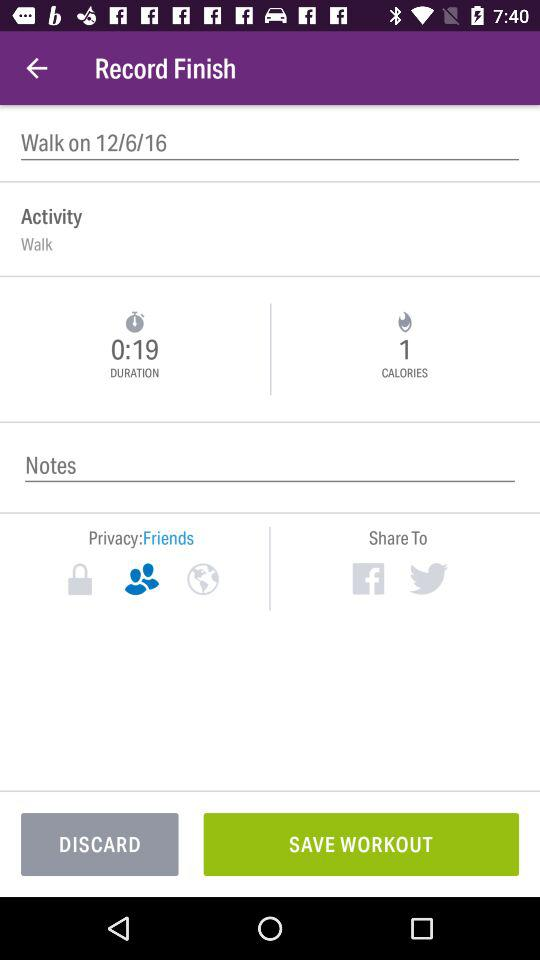How many calories were burned during this workout?
Answer the question using a single word or phrase. 1 